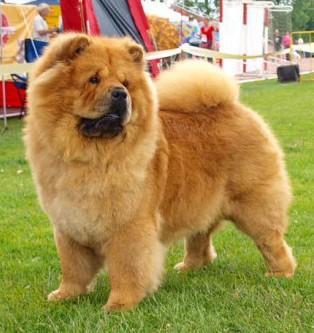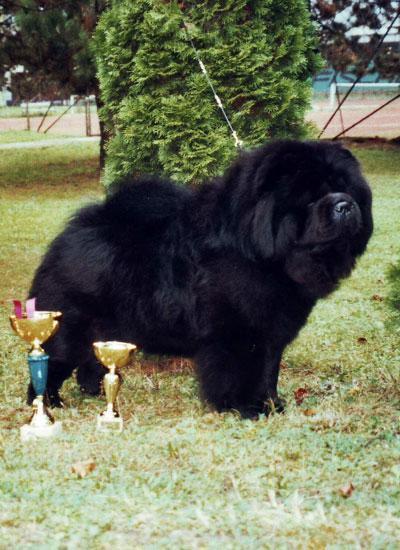The first image is the image on the left, the second image is the image on the right. For the images displayed, is the sentence "The right image contains exactly one chow whose body is facing towards the left and their face is looking at the camera." factually correct? Answer yes or no. No. The first image is the image on the left, the second image is the image on the right. Given the left and right images, does the statement "There are only two brown dogs in the pair of images." hold true? Answer yes or no. No. 